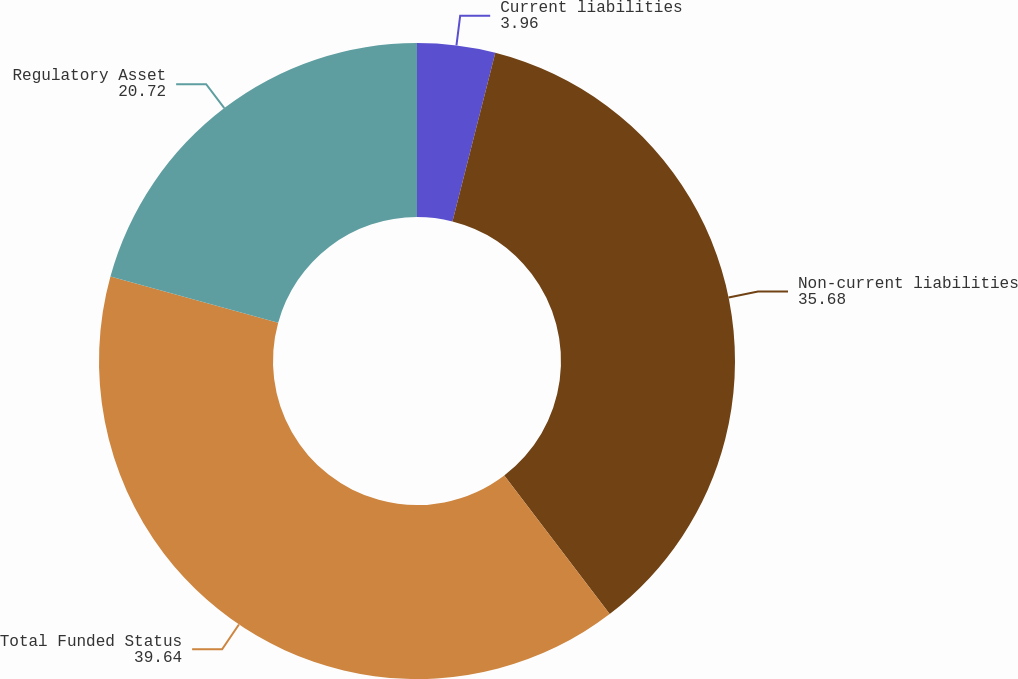Convert chart. <chart><loc_0><loc_0><loc_500><loc_500><pie_chart><fcel>Current liabilities<fcel>Non-current liabilities<fcel>Total Funded Status<fcel>Regulatory Asset<nl><fcel>3.96%<fcel>35.68%<fcel>39.64%<fcel>20.72%<nl></chart> 